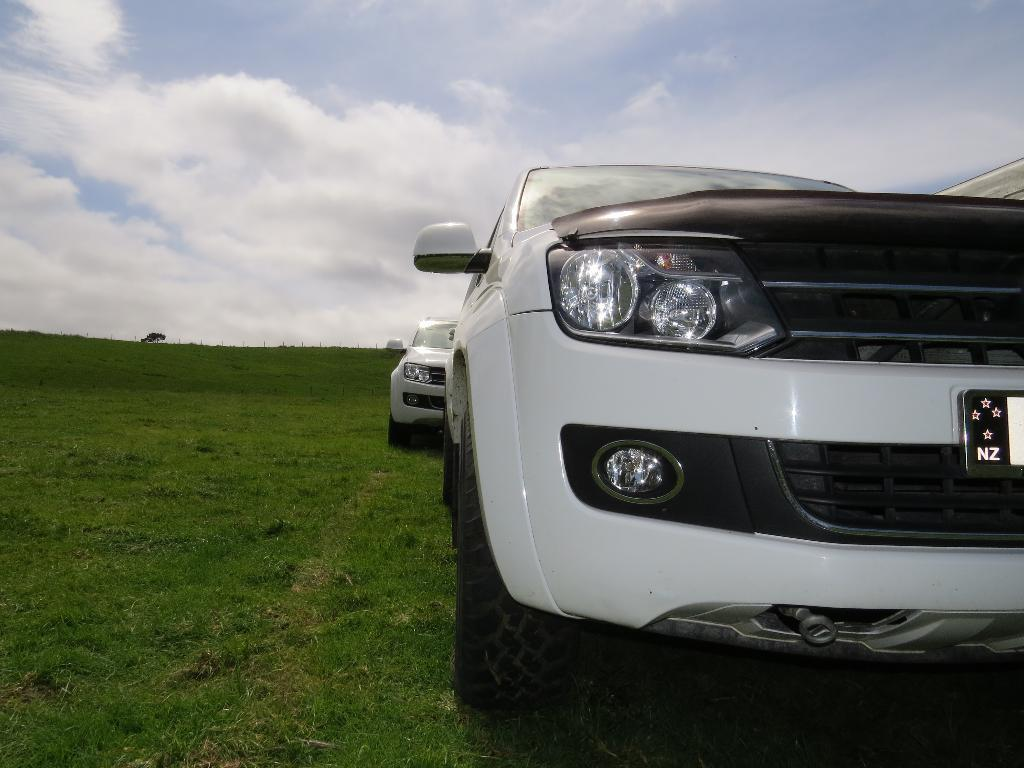How many cars can be seen in the image? There are two cars in the image. What color are the cars? The cars are white in color. What can be seen in the background of the image? There is a sky, clouds, and grass visible in the background of the image. What invention is being demonstrated by the crying boot in the image? There is no boot, crying or otherwise, present in the image. 